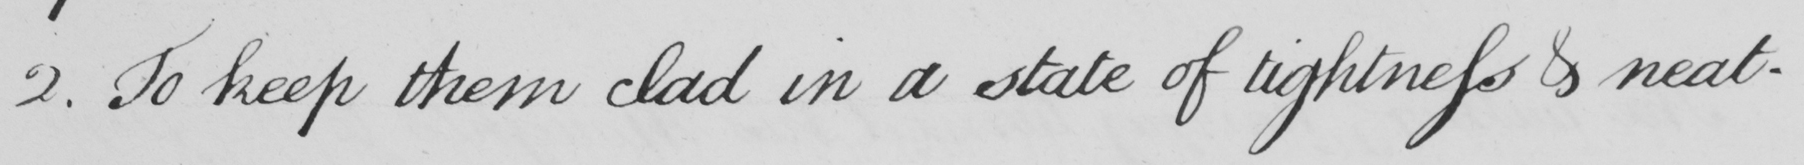What text is written in this handwritten line? 2. To keep them clad in a state of lightness & neat- 